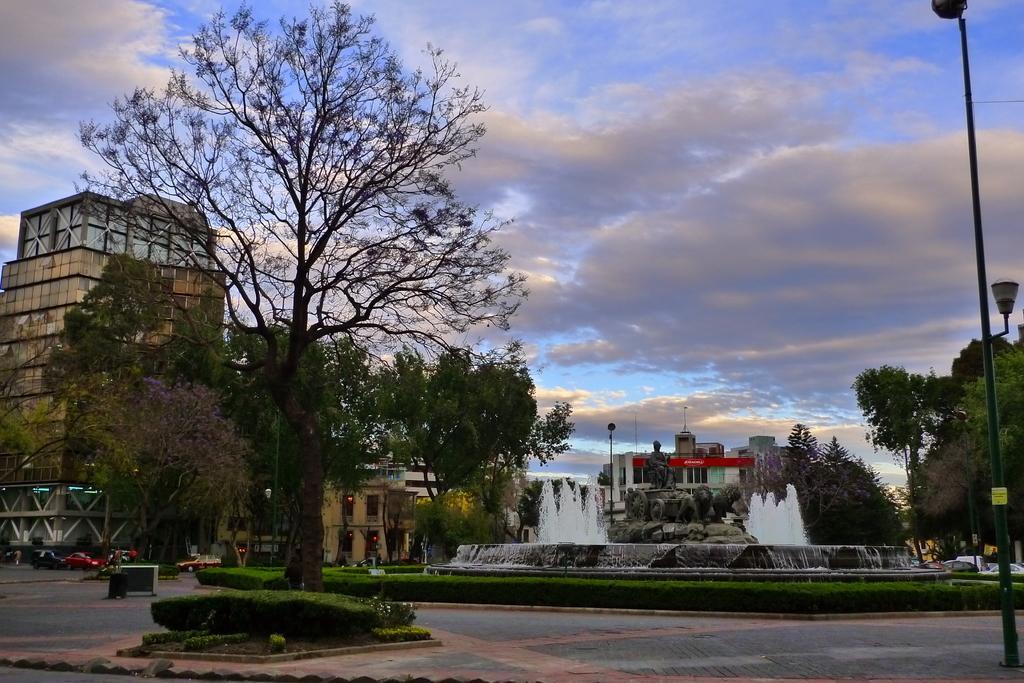Please provide a concise description of this image. In this image, we can see so many trees, water fountain, statue, poles with lights, houses, buildings. Vehicles are on the road. At the bottom, we can see few plants, platform. Top of the image, there is a cloudy sky. 